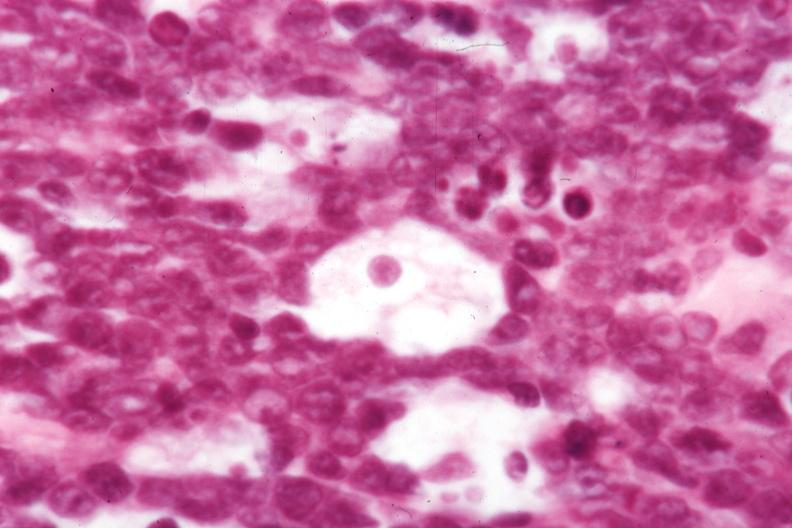what does this image show?
Answer the question using a single word or phrase. Not the best histology 